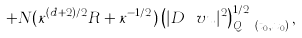<formula> <loc_0><loc_0><loc_500><loc_500>+ N ( \kappa ^ { ( d + 2 ) / 2 } R + \kappa ^ { - 1 / 2 } ) \left ( | D \ v u | ^ { 2 } \right ) _ { Q _ { \nu \kappa r } ( t _ { 0 } , x _ { 0 } ) } ^ { 1 / 2 } ,</formula> 